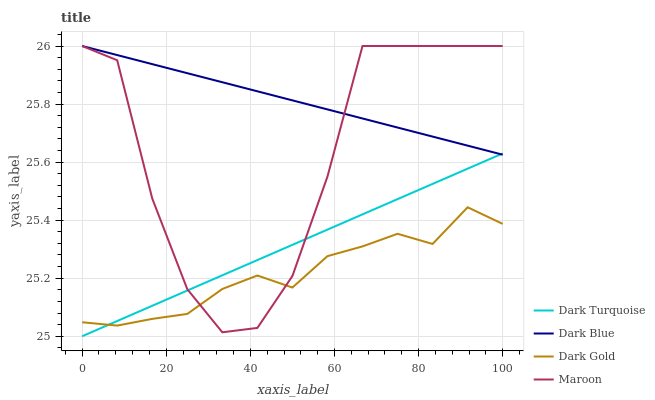Does Maroon have the minimum area under the curve?
Answer yes or no. No. Does Maroon have the maximum area under the curve?
Answer yes or no. No. Is Dark Gold the smoothest?
Answer yes or no. No. Is Dark Gold the roughest?
Answer yes or no. No. Does Dark Gold have the lowest value?
Answer yes or no. No. Does Dark Gold have the highest value?
Answer yes or no. No. Is Dark Gold less than Dark Blue?
Answer yes or no. Yes. Is Dark Blue greater than Dark Gold?
Answer yes or no. Yes. Does Dark Gold intersect Dark Blue?
Answer yes or no. No. 